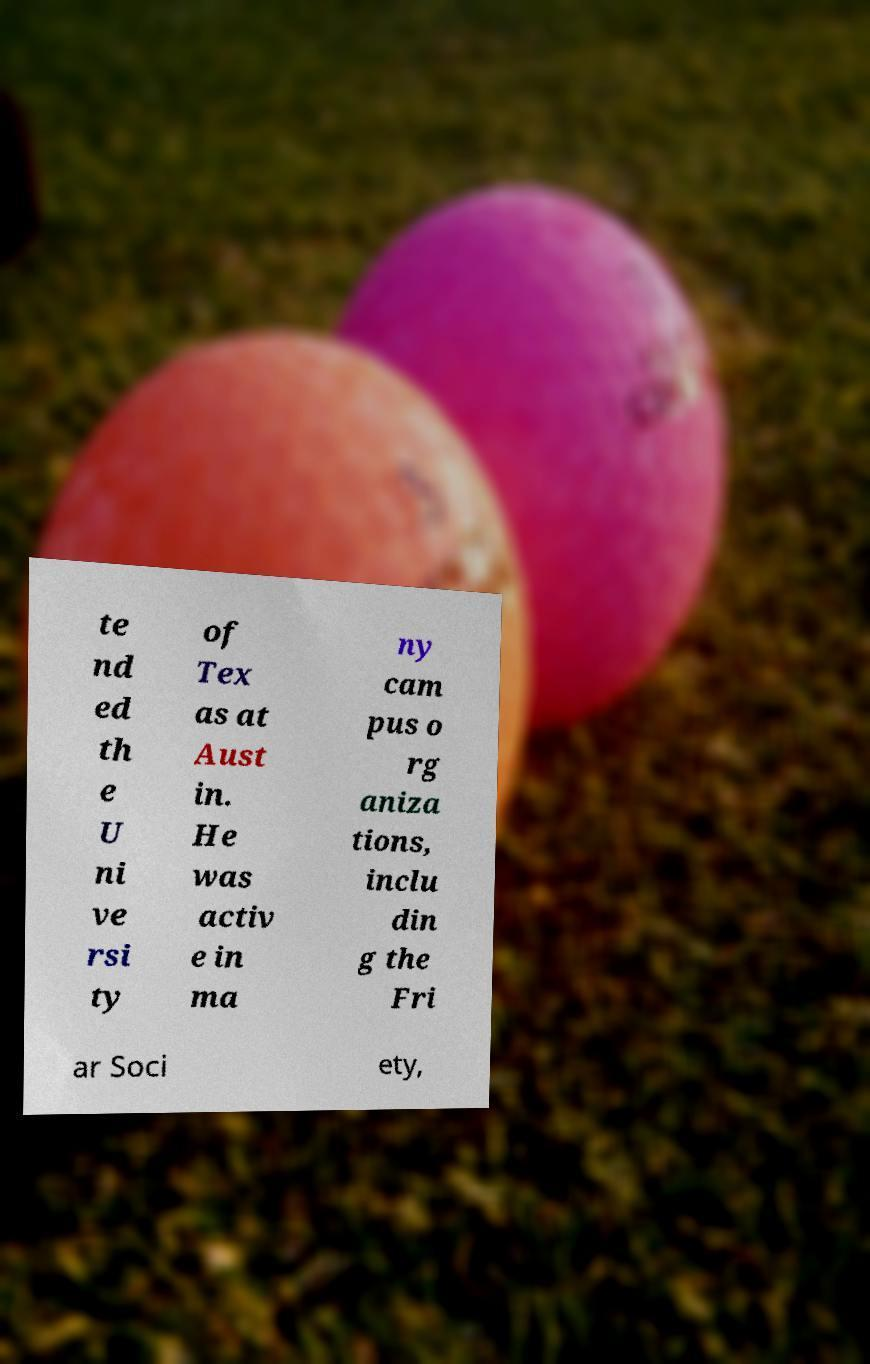Can you accurately transcribe the text from the provided image for me? te nd ed th e U ni ve rsi ty of Tex as at Aust in. He was activ e in ma ny cam pus o rg aniza tions, inclu din g the Fri ar Soci ety, 